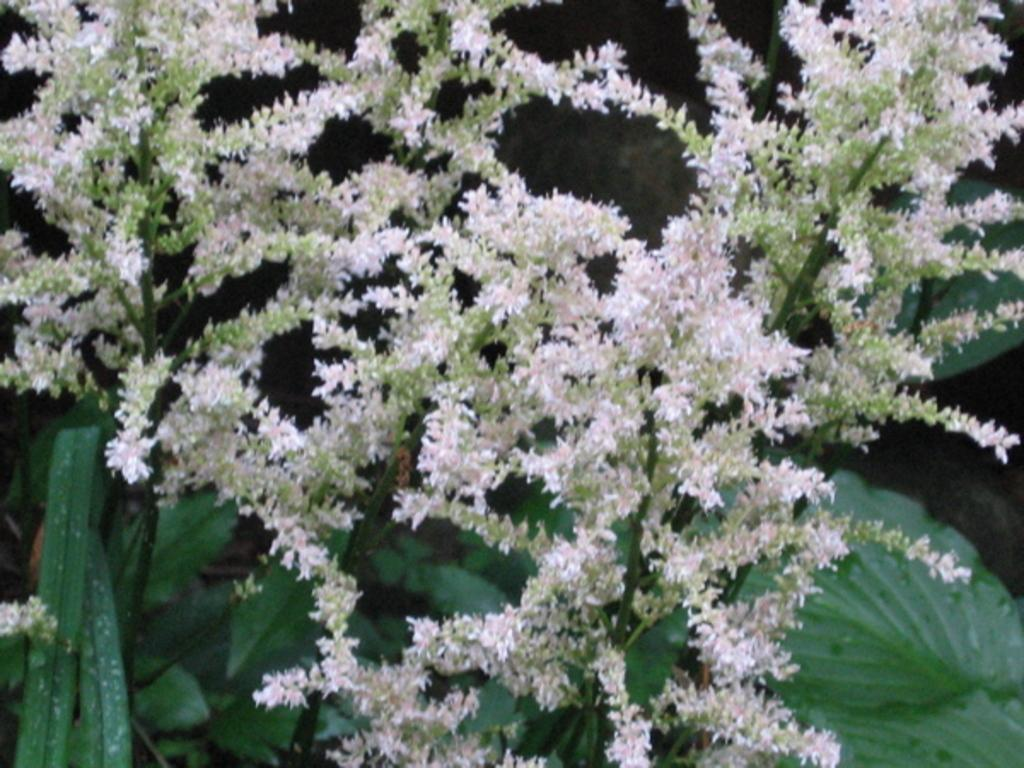What type of plants can be seen in the image? There are flowers and leaves in the image. Can you describe the appearance of the flowers? Unfortunately, the specific appearance of the flowers cannot be determined from the provided facts. Are there any other elements present in the image besides the flowers and leaves? No additional elements are mentioned in the provided facts. How many cannons are present in the image? There are no cannons present in the image; it features flowers and leaves. What type of power source is used to operate the clocks in the image? There are no clocks present in the image, as it only features flowers and leaves. 